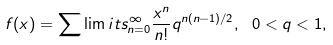<formula> <loc_0><loc_0><loc_500><loc_500>f ( x ) = \sum \lim i t s _ { n = 0 } ^ { \infty } { \frac { x ^ { n } } { n ! } { q ^ { n ( n - 1 ) / 2 } } } , \ 0 < q < 1 ,</formula> 